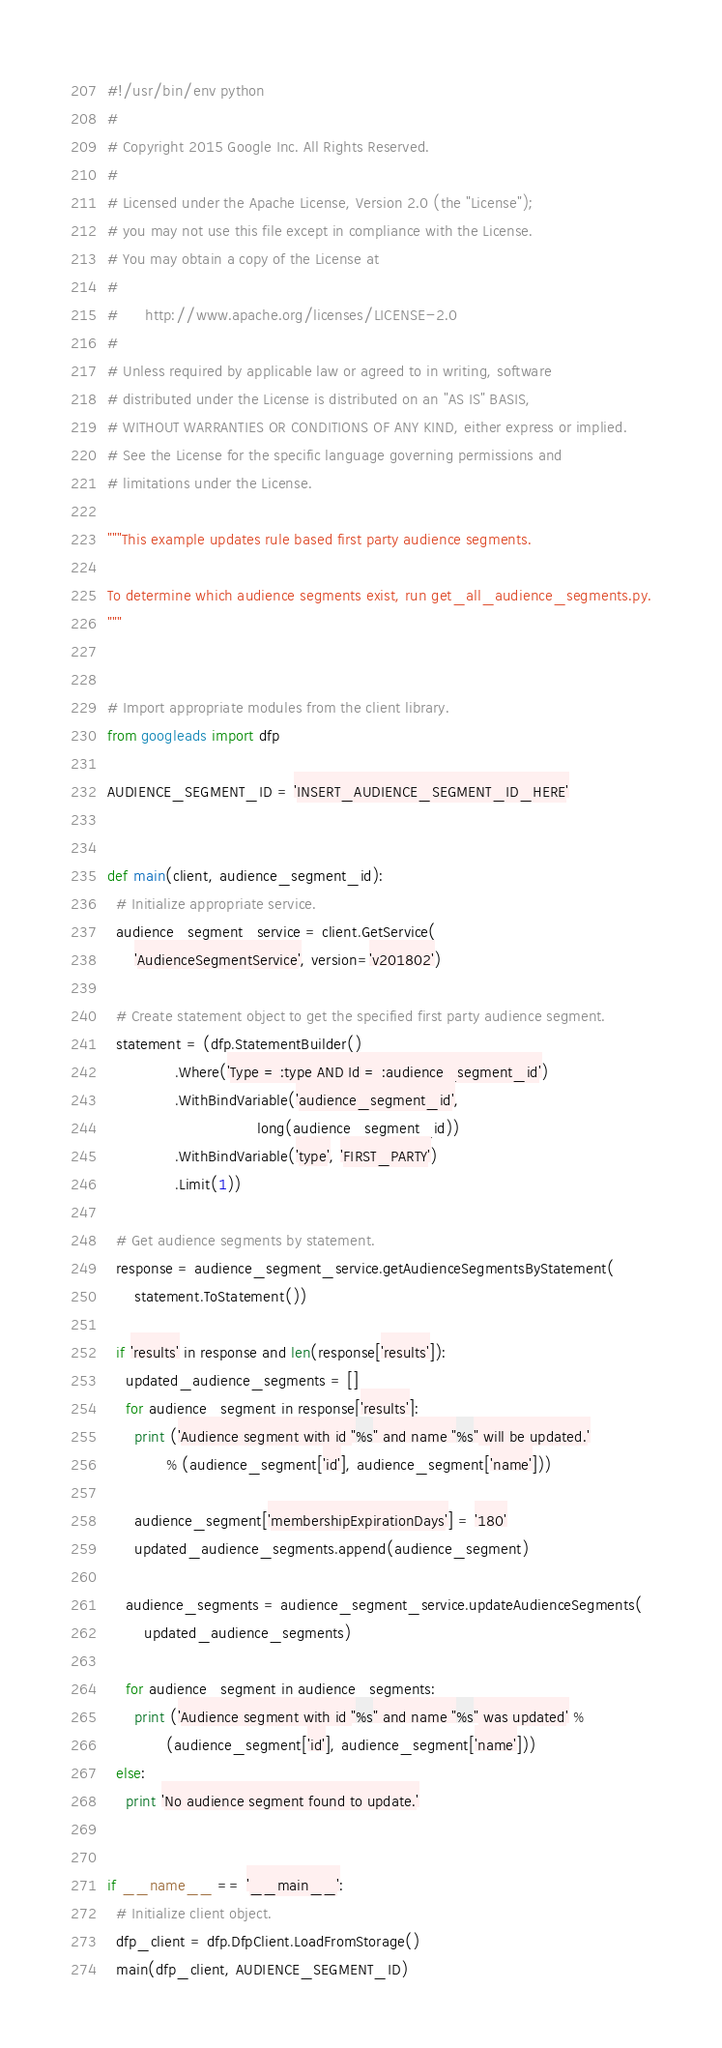<code> <loc_0><loc_0><loc_500><loc_500><_Python_>#!/usr/bin/env python
#
# Copyright 2015 Google Inc. All Rights Reserved.
#
# Licensed under the Apache License, Version 2.0 (the "License");
# you may not use this file except in compliance with the License.
# You may obtain a copy of the License at
#
#      http://www.apache.org/licenses/LICENSE-2.0
#
# Unless required by applicable law or agreed to in writing, software
# distributed under the License is distributed on an "AS IS" BASIS,
# WITHOUT WARRANTIES OR CONDITIONS OF ANY KIND, either express or implied.
# See the License for the specific language governing permissions and
# limitations under the License.

"""This example updates rule based first party audience segments.

To determine which audience segments exist, run get_all_audience_segments.py.
"""


# Import appropriate modules from the client library.
from googleads import dfp

AUDIENCE_SEGMENT_ID = 'INSERT_AUDIENCE_SEGMENT_ID_HERE'


def main(client, audience_segment_id):
  # Initialize appropriate service.
  audience_segment_service = client.GetService(
      'AudienceSegmentService', version='v201802')

  # Create statement object to get the specified first party audience segment.
  statement = (dfp.StatementBuilder()
               .Where('Type = :type AND Id = :audience_segment_id')
               .WithBindVariable('audience_segment_id',
                                 long(audience_segment_id))
               .WithBindVariable('type', 'FIRST_PARTY')
               .Limit(1))

  # Get audience segments by statement.
  response = audience_segment_service.getAudienceSegmentsByStatement(
      statement.ToStatement())

  if 'results' in response and len(response['results']):
    updated_audience_segments = []
    for audience_segment in response['results']:
      print ('Audience segment with id "%s" and name "%s" will be updated.'
             % (audience_segment['id'], audience_segment['name']))

      audience_segment['membershipExpirationDays'] = '180'
      updated_audience_segments.append(audience_segment)

    audience_segments = audience_segment_service.updateAudienceSegments(
        updated_audience_segments)

    for audience_segment in audience_segments:
      print ('Audience segment with id "%s" and name "%s" was updated' %
             (audience_segment['id'], audience_segment['name']))
  else:
    print 'No audience segment found to update.'


if __name__ == '__main__':
  # Initialize client object.
  dfp_client = dfp.DfpClient.LoadFromStorage()
  main(dfp_client, AUDIENCE_SEGMENT_ID)
</code> 